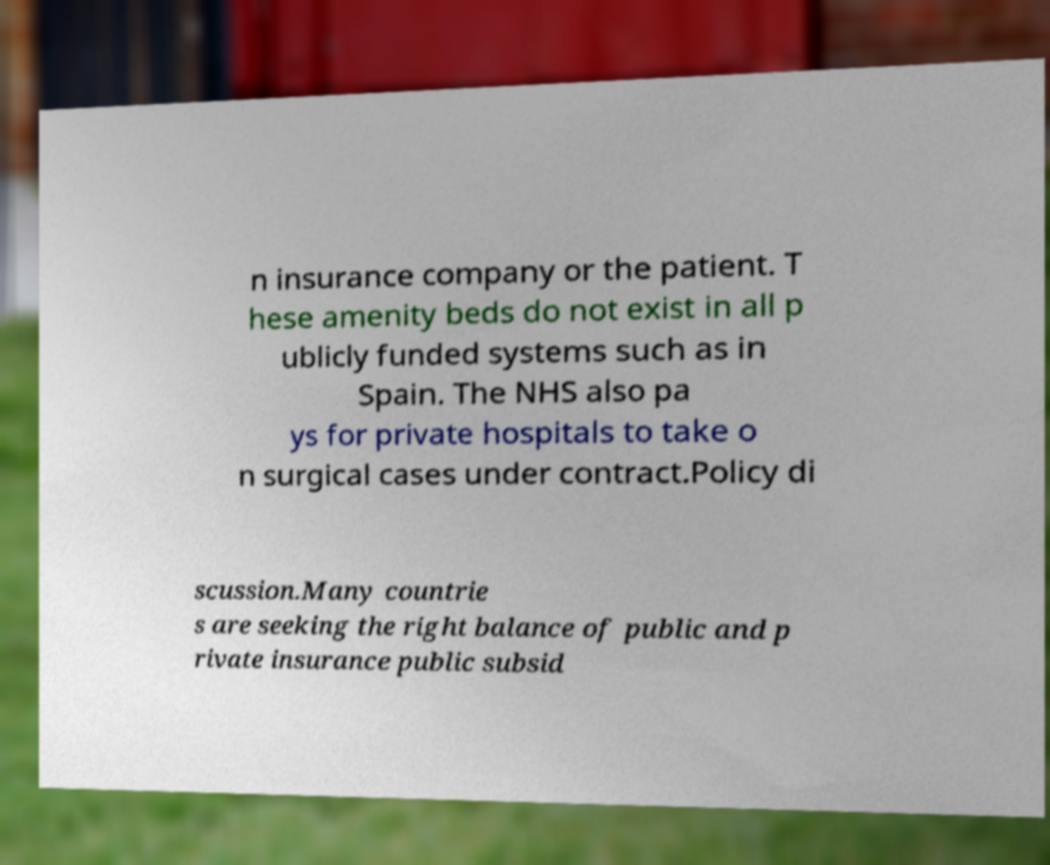What messages or text are displayed in this image? I need them in a readable, typed format. n insurance company or the patient. T hese amenity beds do not exist in all p ublicly funded systems such as in Spain. The NHS also pa ys for private hospitals to take o n surgical cases under contract.Policy di scussion.Many countrie s are seeking the right balance of public and p rivate insurance public subsid 